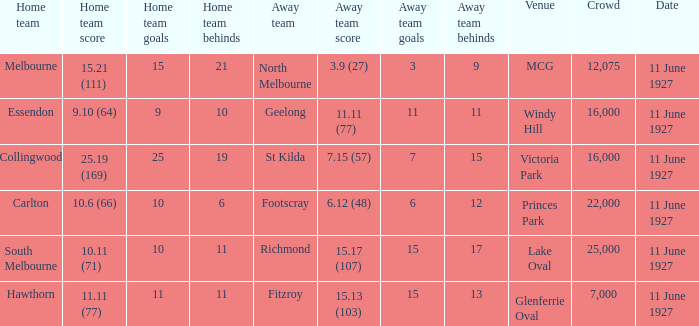What is the total number of people gathered at the glenferrie oval venue? 7000.0. 